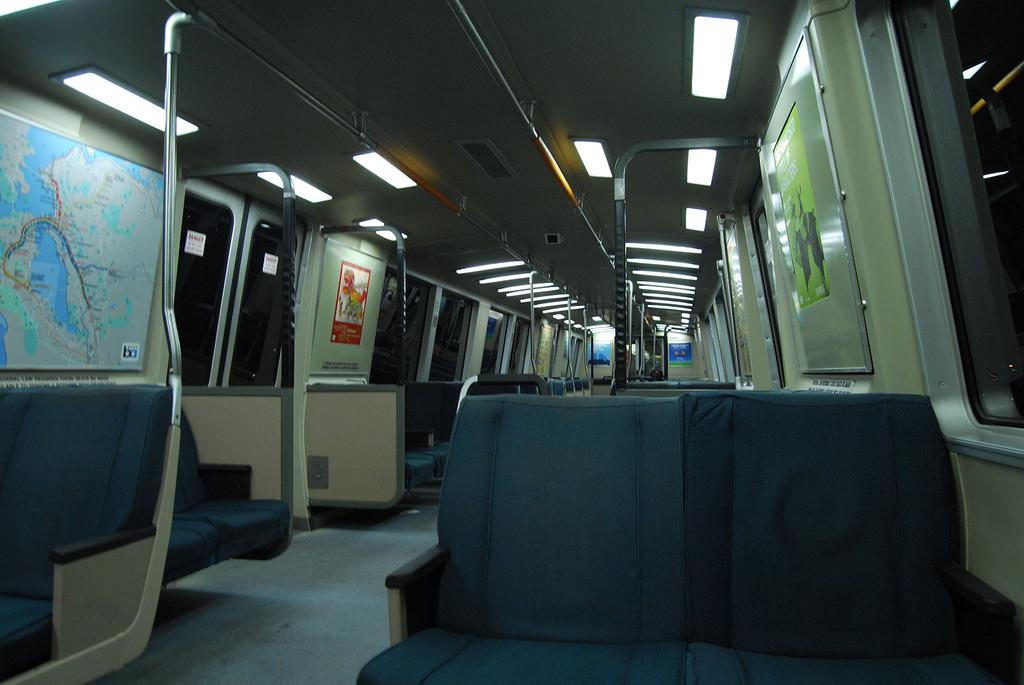What type of vehicle is shown in the image? The image depicts the interior of a train. What can be observed about the seating arrangement in the train? There are empty seats in the train. Are there any other objects present in the train? Yes, there are other objects present in the train. What is attached to the roof of the train? There are lights attached to the roof of the train. What type of flag is visible on the back of the train? There is no flag visible on the back of the train in the image. Can you describe the tail of the train in the image? There is no tail present in the image, as it depicts the interior of a train. 